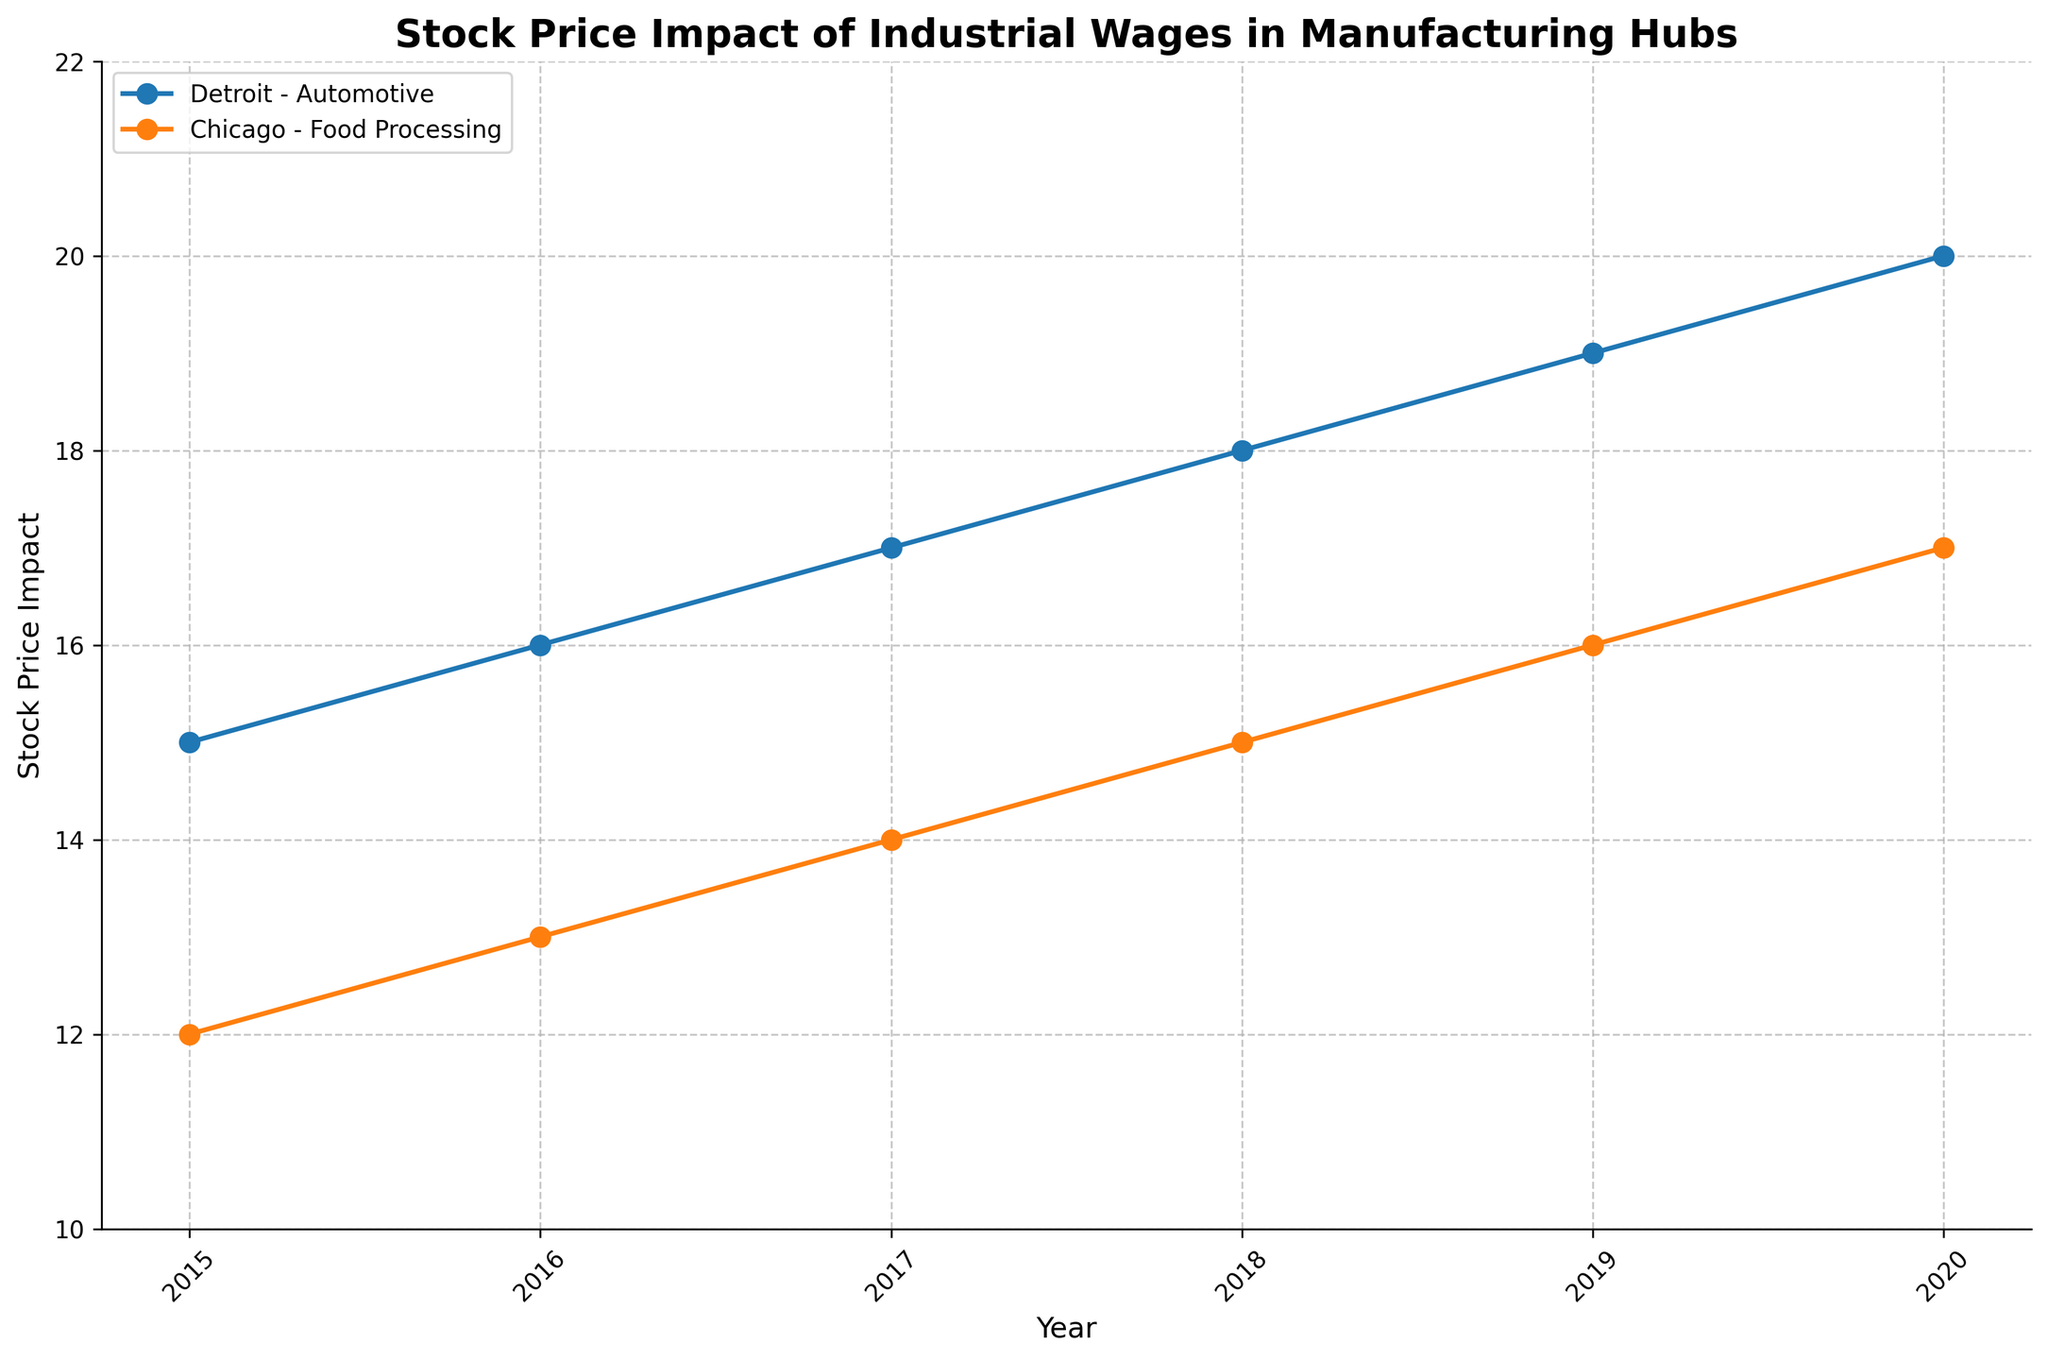1. What is the title of the figure? At the top of the figure, the title is clearly displayed.
Answer: Stock Price Impact of Industrial Wages in Manufacturing Hubs 2. Which location shows a higher stock price impact in 2020? By comparing the stock price impacts for both Detroit and Chicago at the final data point (2020), we see that Detroit has a higher value.
Answer: Detroit 3. How many locations are compared in the figure? Observing the legend and lines in the plot, there are two distinct locations represented.
Answer: Two 4. What is the stock price impact for Detroit in 2017? By pinpointing the 2017 data point for Detroit on the x-axis and observing the corresponding y-axis value, we obtain the stock price impact.
Answer: 17 5. Is there a year when both locations have the same stock price impact? By examining each year’s data points for both locations, we determine whether their stock price impacts are identical in any year. There is no year where both lines intersect at the same stock price impact level.
Answer: No 6. What is the trend in stock price impact for Detroit from 2015 to 2020? Observing the Detroit line on the plot, we see a consistent upward trend from the starting year 2015 to 2020.
Answer: Increasing 7. What is the average stock price impact for Chicago over the period shown? To calculate the average, sum up the stock price impacts for Chicago (12, 13, 14, 15, 16, 17), then divide by the number of data points (6). The sum is 87, and the average is calculated as 87/6.
Answer: 14.5 8. By how much did the stock price impact for Detroit increase from 2015 to 2020? Subtract the stock price impact in 2015 for Detroit (15) from the stock price impact in 2020 (20).
Answer: 5 9. Between 2018 and 2019, which location showed a greater increase in stock price impact? Calculate the increase for each location: Detroit's increase is (19 - 18) = 1 and Chicago's increase is (16 - 15) = 1. They both have the same increase.
Answer: Both 10. Is there a clear leader in terms of stock price impact among the two locations throughout the period? By visually comparing the lines, Detroit consistently has higher stock price impacts than Chicago throughout all years.
Answer: Yes, Detroit 